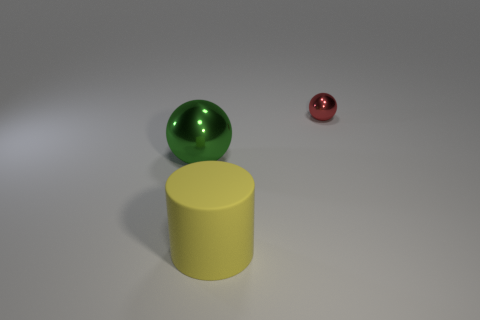Add 1 red metallic balls. How many objects exist? 4 Subtract all balls. How many objects are left? 1 Subtract 0 brown cylinders. How many objects are left? 3 Subtract all tiny blue rubber things. Subtract all large green shiny objects. How many objects are left? 2 Add 2 large green metal things. How many large green metal things are left? 3 Add 3 tiny yellow matte things. How many tiny yellow matte things exist? 3 